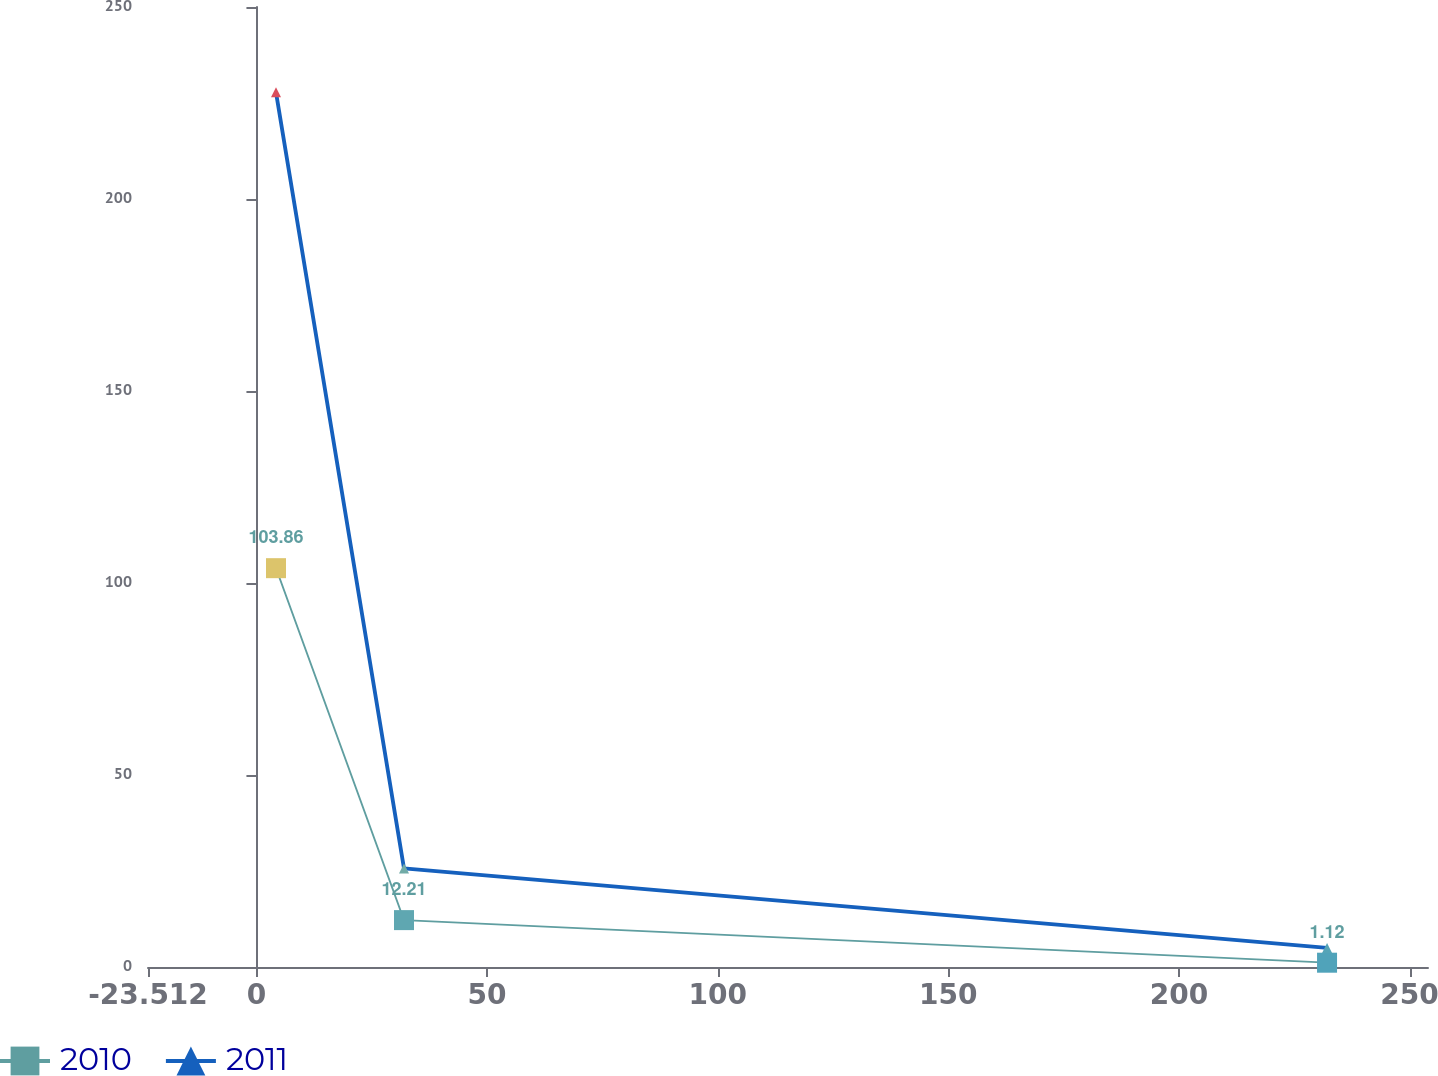Convert chart. <chart><loc_0><loc_0><loc_500><loc_500><line_chart><ecel><fcel>2010<fcel>2011<nl><fcel>4.24<fcel>103.86<fcel>227.78<nl><fcel>31.99<fcel>12.21<fcel>25.68<nl><fcel>232.12<fcel>1.12<fcel>4.97<nl><fcel>281.76<fcel>38.79<fcel>207.07<nl></chart> 